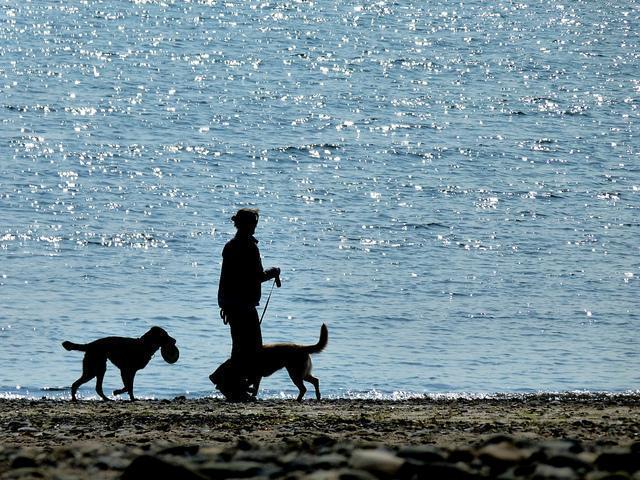How many dogs are there?
Give a very brief answer. 2. How many people are there?
Give a very brief answer. 1. How many dogs are in the picture?
Give a very brief answer. 2. 